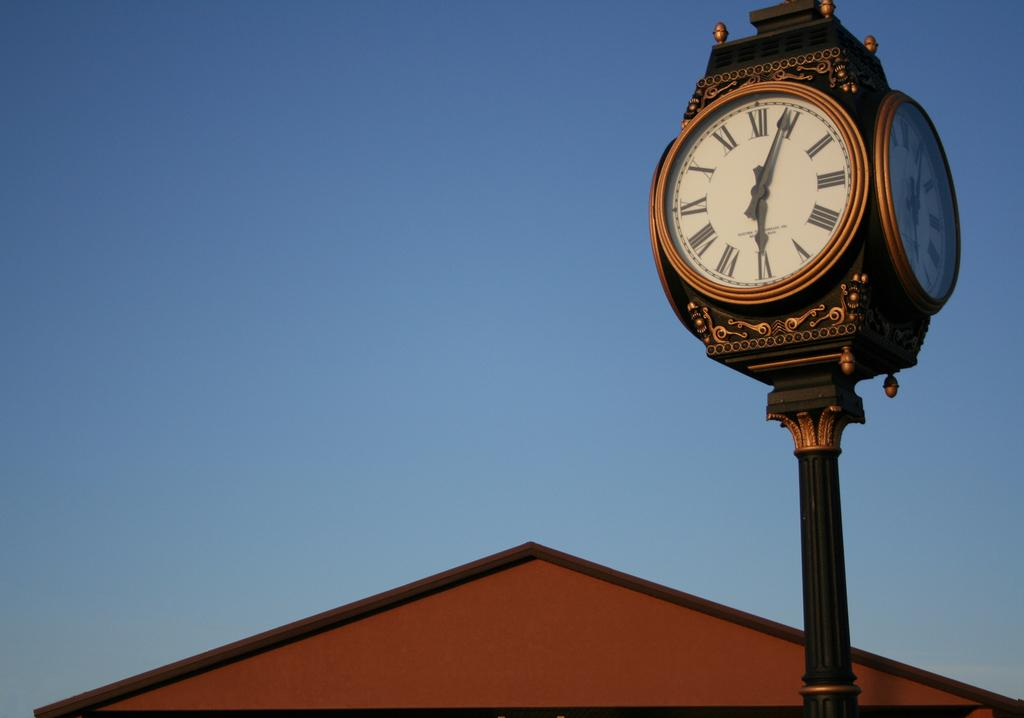<image>
Give a short and clear explanation of the subsequent image. A large decorative clock shows the time as 6:05 